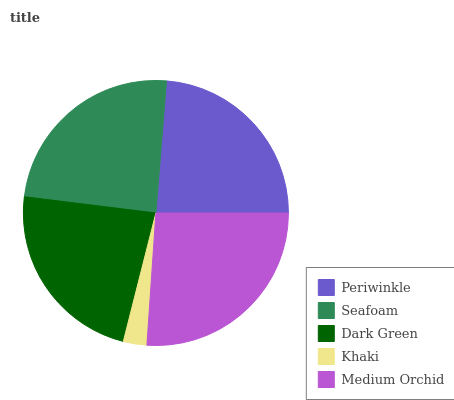Is Khaki the minimum?
Answer yes or no. Yes. Is Medium Orchid the maximum?
Answer yes or no. Yes. Is Seafoam the minimum?
Answer yes or no. No. Is Seafoam the maximum?
Answer yes or no. No. Is Seafoam greater than Periwinkle?
Answer yes or no. Yes. Is Periwinkle less than Seafoam?
Answer yes or no. Yes. Is Periwinkle greater than Seafoam?
Answer yes or no. No. Is Seafoam less than Periwinkle?
Answer yes or no. No. Is Periwinkle the high median?
Answer yes or no. Yes. Is Periwinkle the low median?
Answer yes or no. Yes. Is Seafoam the high median?
Answer yes or no. No. Is Medium Orchid the low median?
Answer yes or no. No. 